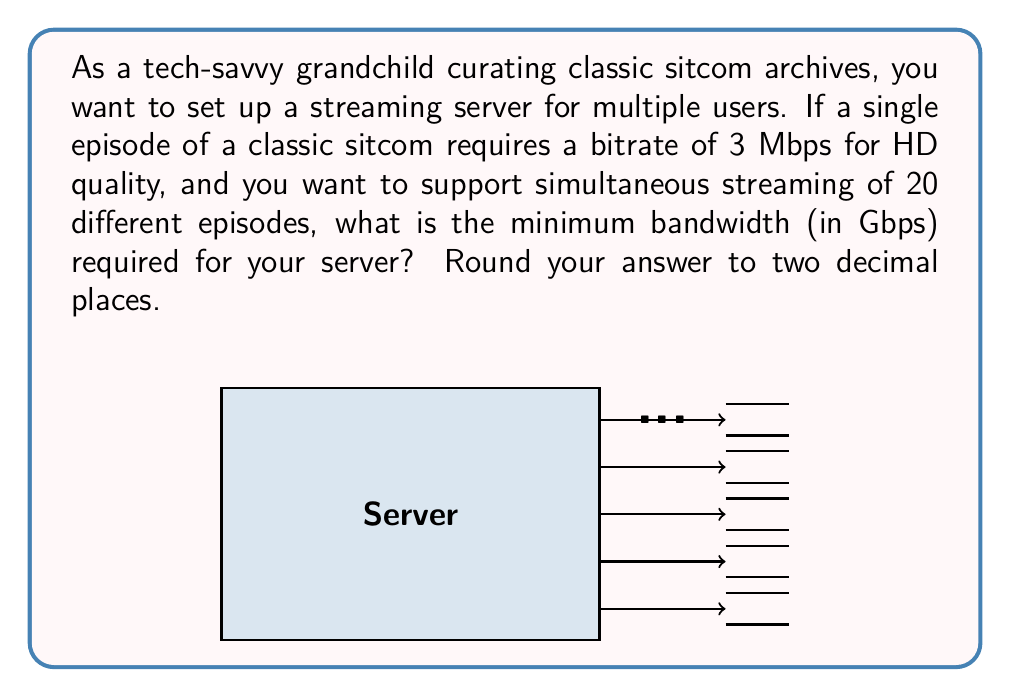Teach me how to tackle this problem. To solve this problem, we need to follow these steps:

1) First, let's identify the given information:
   - Single episode bitrate: 3 Mbps
   - Number of simultaneous streams: 20

2) To find the total bandwidth required, we need to multiply the bitrate per episode by the number of simultaneous streams:

   $$ \text{Total bandwidth} = 3 \text{ Mbps} \times 20 = 60 \text{ Mbps} $$

3) The question asks for the answer in Gbps (Gigabits per second). We need to convert Mbps to Gbps:

   $$ 60 \text{ Mbps} = 60 \div 1000 \text{ Gbps} = 0.06 \text{ Gbps} $$

4) Rounding to two decimal places:

   $$ 0.06 \text{ Gbps} \approx 0.06 \text{ Gbps} $$

Therefore, the minimum bandwidth required for the server is 0.06 Gbps.
Answer: 0.06 Gbps 